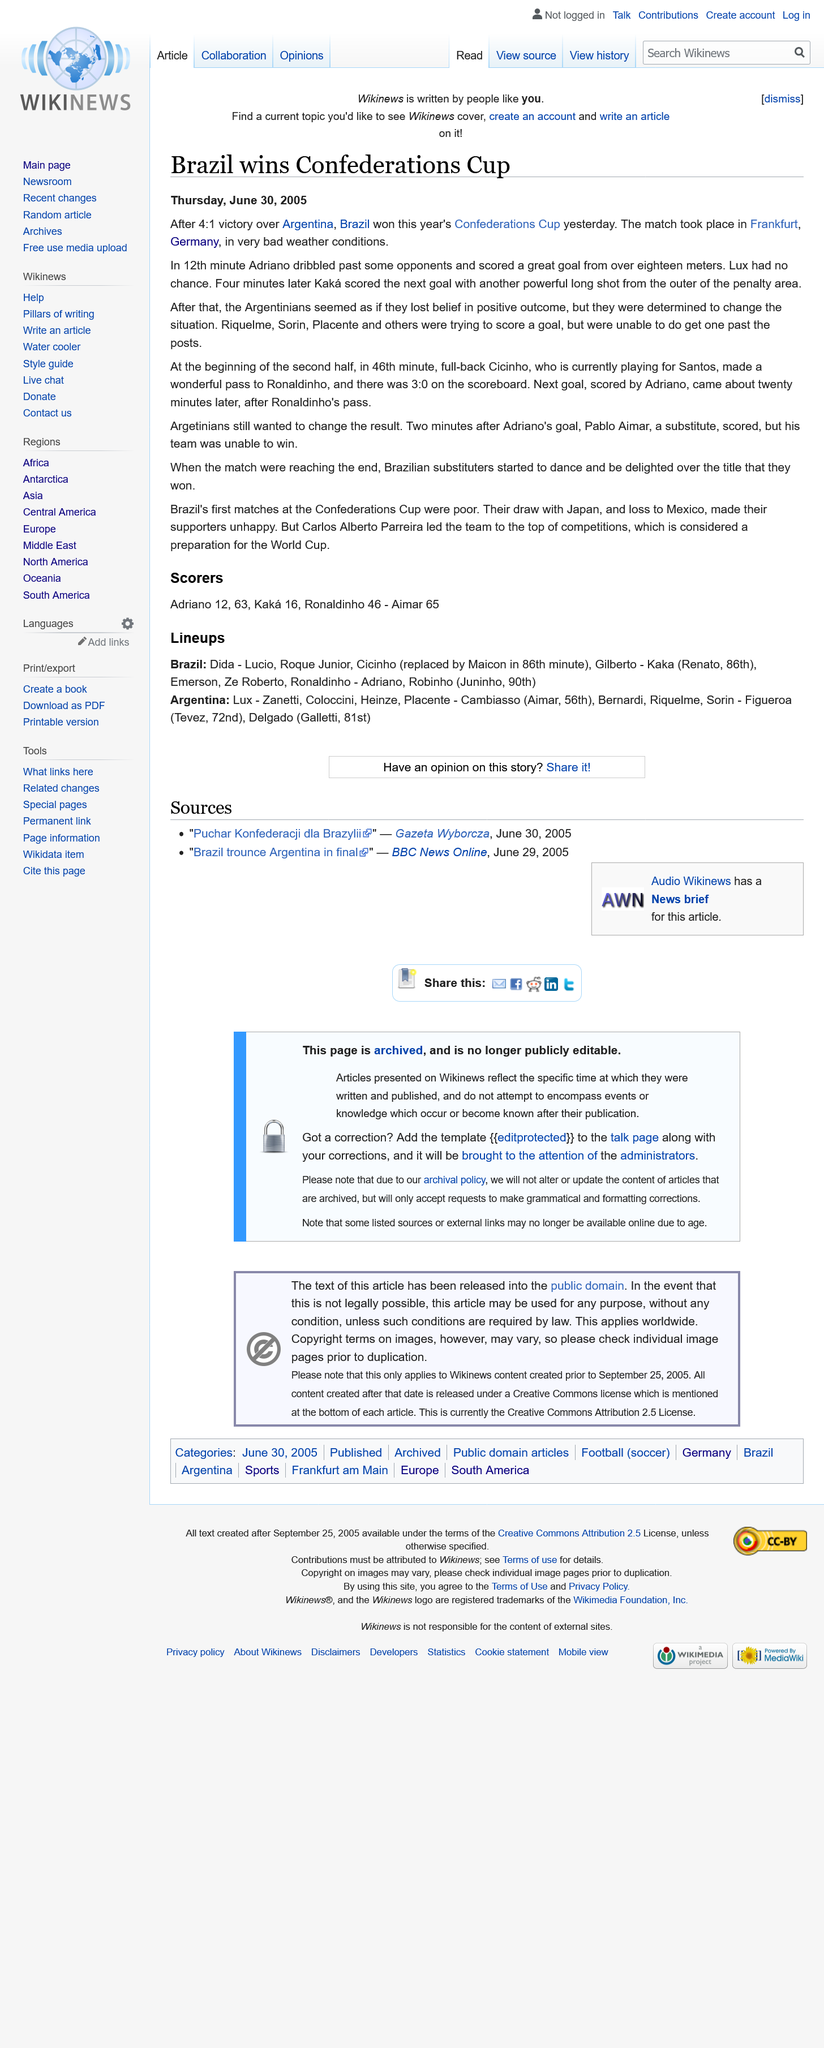Point out several critical features in this image. The match took place in Frankfurt, Germany. Brazil emerged victorious over Argentina in a landslide win with a score of 4-1. The first goal for Brazil was scored by Adriano. 